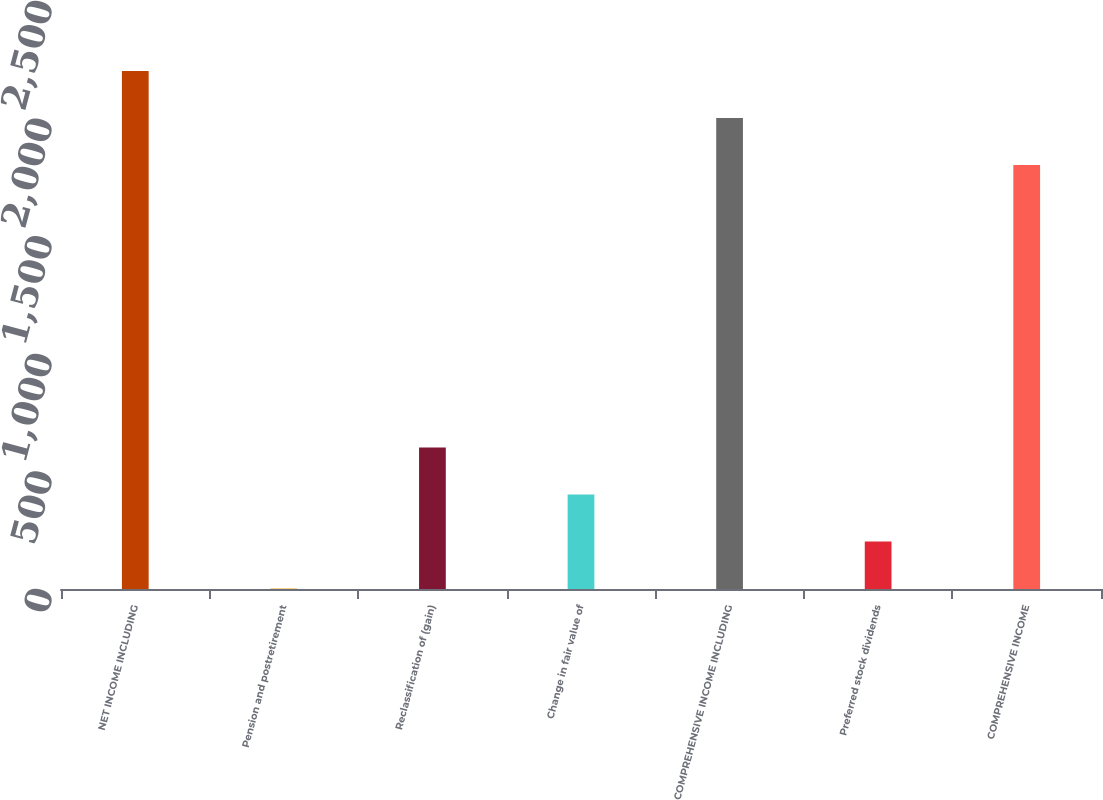Convert chart. <chart><loc_0><loc_0><loc_500><loc_500><bar_chart><fcel>NET INCOME INCLUDING<fcel>Pension and postretirement<fcel>Reclassification of (gain)<fcel>Change in fair value of<fcel>COMPREHENSIVE INCOME INCLUDING<fcel>Preferred stock dividends<fcel>COMPREHENSIVE INCOME<nl><fcel>2202.8<fcel>2<fcel>601.7<fcel>401.8<fcel>2002.9<fcel>201.9<fcel>1803<nl></chart> 